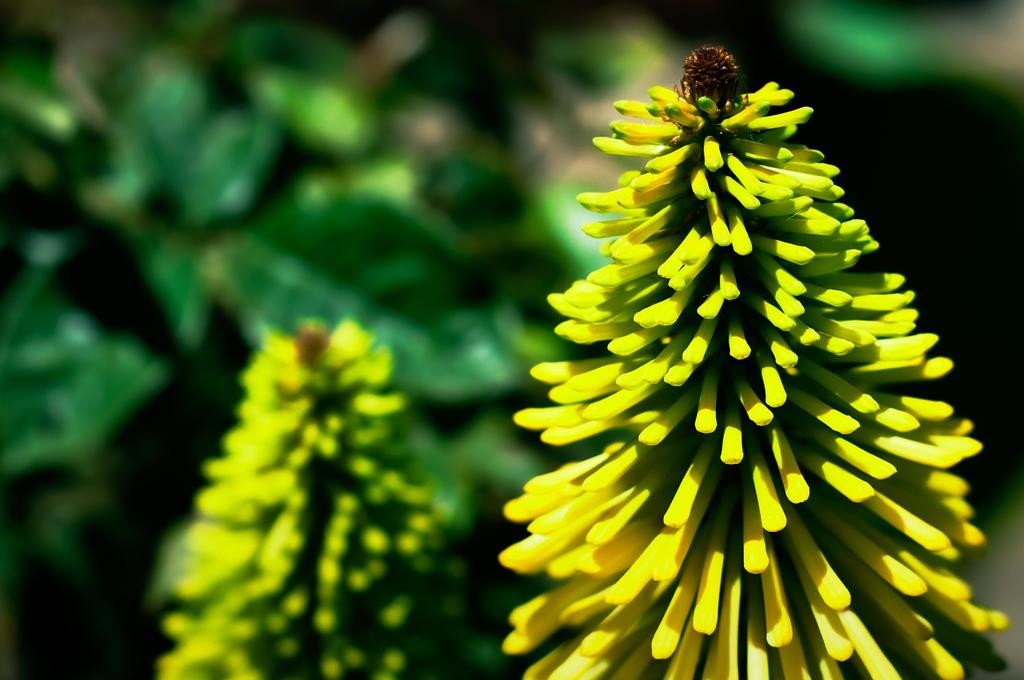What is present in the image? There is a plant in the image. What is the current stage of the plant's growth? The plant has buds. What color are the buds? The buds are in yellow color. How many waves can be seen crashing on the shore in the image? There are no waves or shore present in the image; it features a plant with yellow buds. What type of sticks are used to support the plant in the image? There are no sticks visible in the image; the plant is standing on its own. 